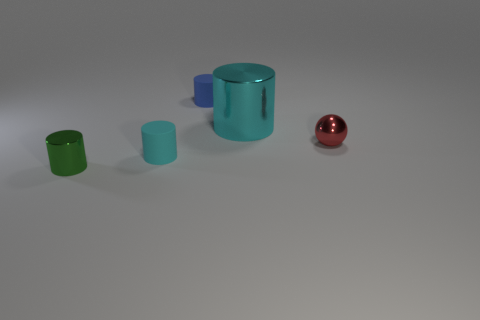How many cylinders are either large purple things or tiny cyan matte objects?
Ensure brevity in your answer.  1. Is there a green matte cylinder?
Your response must be concise. No. What is the size of the blue rubber object that is the same shape as the big cyan shiny thing?
Offer a very short reply. Small. There is a small shiny thing that is right of the small shiny thing to the left of the blue object; what is its shape?
Your answer should be compact. Sphere. How many purple things are cylinders or small metal objects?
Provide a short and direct response. 0. What is the color of the ball?
Keep it short and to the point. Red. Do the cyan rubber object and the cyan metallic cylinder have the same size?
Make the answer very short. No. Are there any other things that have the same shape as the large metal object?
Provide a succinct answer. Yes. Does the green cylinder have the same material as the small object on the right side of the blue rubber cylinder?
Your response must be concise. Yes. There is a matte thing that is in front of the blue cylinder; is it the same color as the large metal cylinder?
Your response must be concise. Yes. 